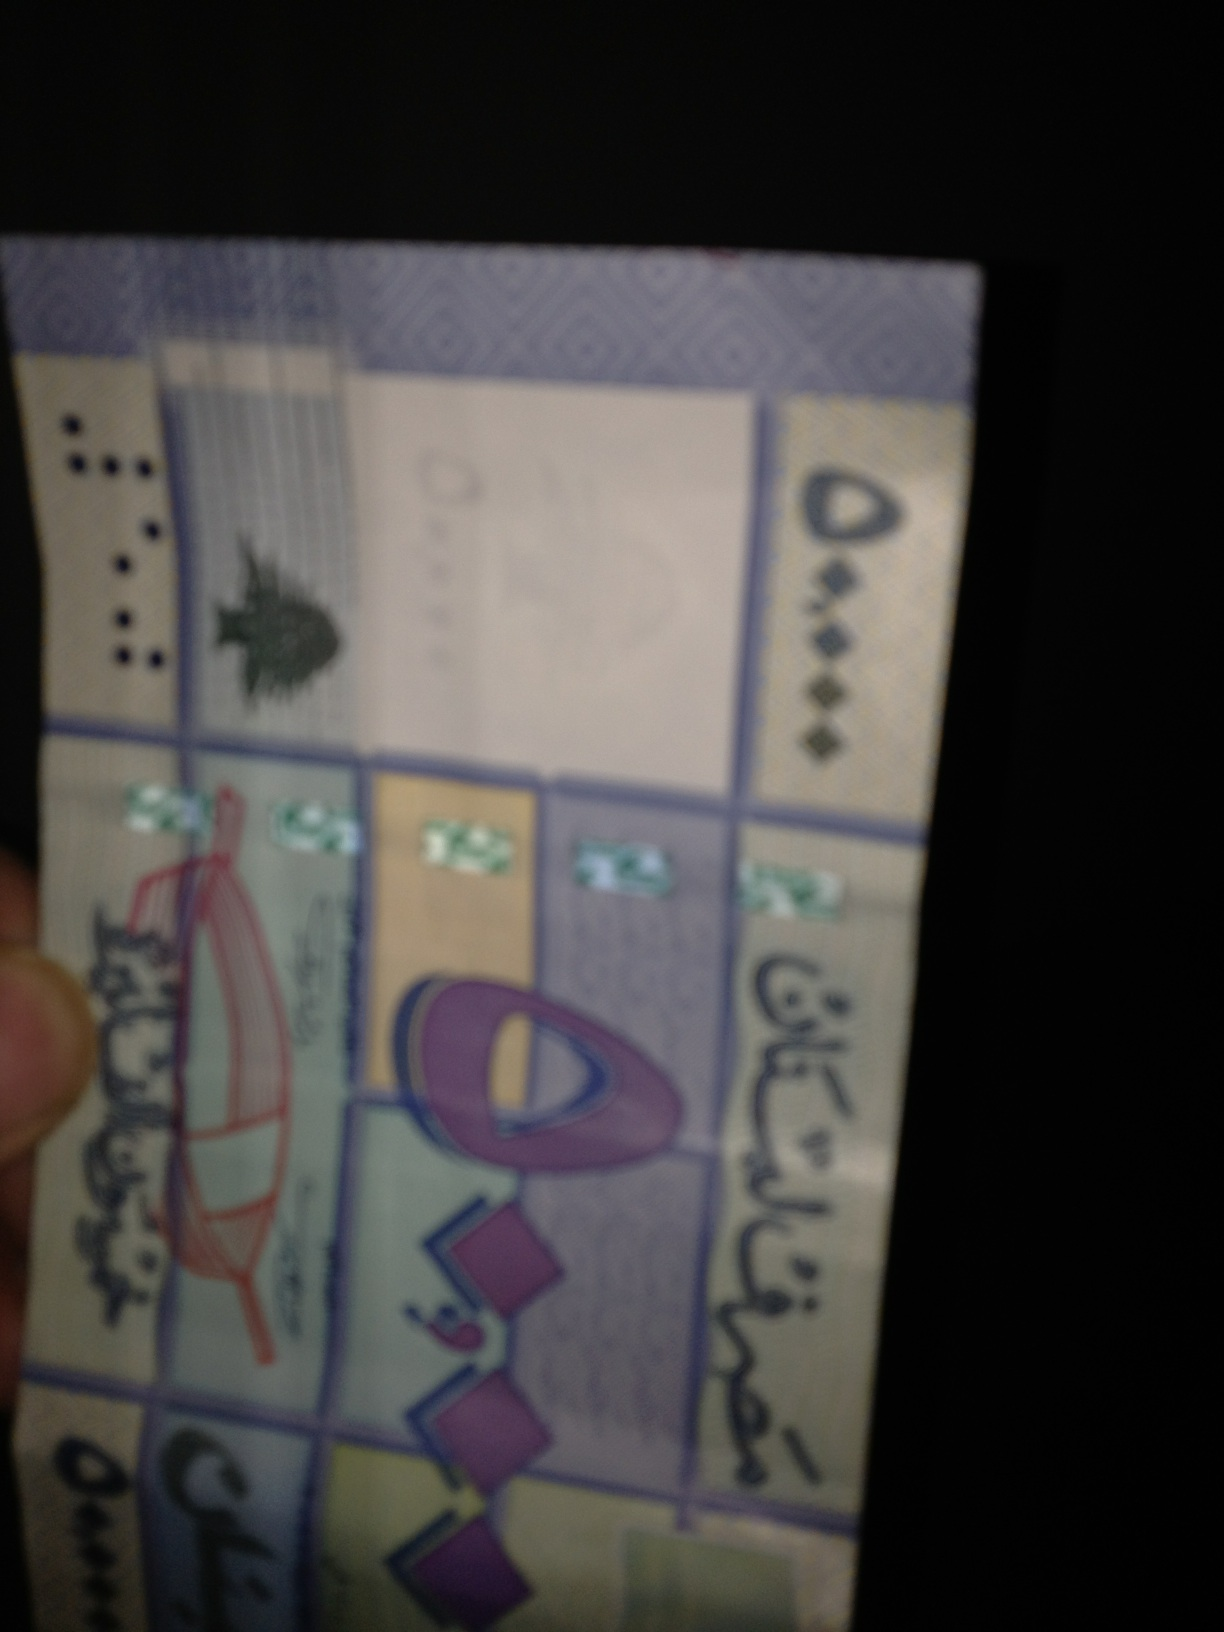Are there any visible security features on this currency that can help identify it? While the specific details are not clear due to the image quality, typical security features on banknotes might include watermarks, security threads, or holographic elements. From what can be seen, there appears to be a reflective feature which could be part of a hologram or a metallic thread. 